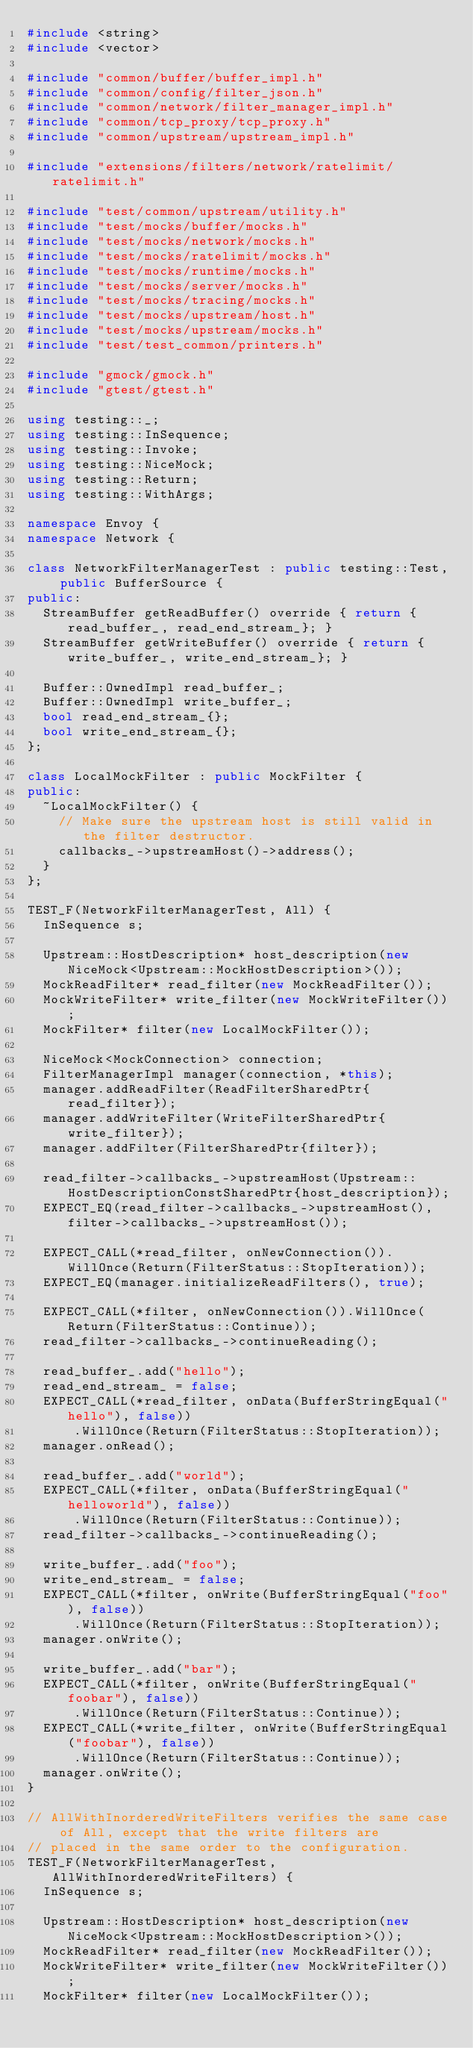Convert code to text. <code><loc_0><loc_0><loc_500><loc_500><_C++_>#include <string>
#include <vector>

#include "common/buffer/buffer_impl.h"
#include "common/config/filter_json.h"
#include "common/network/filter_manager_impl.h"
#include "common/tcp_proxy/tcp_proxy.h"
#include "common/upstream/upstream_impl.h"

#include "extensions/filters/network/ratelimit/ratelimit.h"

#include "test/common/upstream/utility.h"
#include "test/mocks/buffer/mocks.h"
#include "test/mocks/network/mocks.h"
#include "test/mocks/ratelimit/mocks.h"
#include "test/mocks/runtime/mocks.h"
#include "test/mocks/server/mocks.h"
#include "test/mocks/tracing/mocks.h"
#include "test/mocks/upstream/host.h"
#include "test/mocks/upstream/mocks.h"
#include "test/test_common/printers.h"

#include "gmock/gmock.h"
#include "gtest/gtest.h"

using testing::_;
using testing::InSequence;
using testing::Invoke;
using testing::NiceMock;
using testing::Return;
using testing::WithArgs;

namespace Envoy {
namespace Network {

class NetworkFilterManagerTest : public testing::Test, public BufferSource {
public:
  StreamBuffer getReadBuffer() override { return {read_buffer_, read_end_stream_}; }
  StreamBuffer getWriteBuffer() override { return {write_buffer_, write_end_stream_}; }

  Buffer::OwnedImpl read_buffer_;
  Buffer::OwnedImpl write_buffer_;
  bool read_end_stream_{};
  bool write_end_stream_{};
};

class LocalMockFilter : public MockFilter {
public:
  ~LocalMockFilter() {
    // Make sure the upstream host is still valid in the filter destructor.
    callbacks_->upstreamHost()->address();
  }
};

TEST_F(NetworkFilterManagerTest, All) {
  InSequence s;

  Upstream::HostDescription* host_description(new NiceMock<Upstream::MockHostDescription>());
  MockReadFilter* read_filter(new MockReadFilter());
  MockWriteFilter* write_filter(new MockWriteFilter());
  MockFilter* filter(new LocalMockFilter());

  NiceMock<MockConnection> connection;
  FilterManagerImpl manager(connection, *this);
  manager.addReadFilter(ReadFilterSharedPtr{read_filter});
  manager.addWriteFilter(WriteFilterSharedPtr{write_filter});
  manager.addFilter(FilterSharedPtr{filter});

  read_filter->callbacks_->upstreamHost(Upstream::HostDescriptionConstSharedPtr{host_description});
  EXPECT_EQ(read_filter->callbacks_->upstreamHost(), filter->callbacks_->upstreamHost());

  EXPECT_CALL(*read_filter, onNewConnection()).WillOnce(Return(FilterStatus::StopIteration));
  EXPECT_EQ(manager.initializeReadFilters(), true);

  EXPECT_CALL(*filter, onNewConnection()).WillOnce(Return(FilterStatus::Continue));
  read_filter->callbacks_->continueReading();

  read_buffer_.add("hello");
  read_end_stream_ = false;
  EXPECT_CALL(*read_filter, onData(BufferStringEqual("hello"), false))
      .WillOnce(Return(FilterStatus::StopIteration));
  manager.onRead();

  read_buffer_.add("world");
  EXPECT_CALL(*filter, onData(BufferStringEqual("helloworld"), false))
      .WillOnce(Return(FilterStatus::Continue));
  read_filter->callbacks_->continueReading();

  write_buffer_.add("foo");
  write_end_stream_ = false;
  EXPECT_CALL(*filter, onWrite(BufferStringEqual("foo"), false))
      .WillOnce(Return(FilterStatus::StopIteration));
  manager.onWrite();

  write_buffer_.add("bar");
  EXPECT_CALL(*filter, onWrite(BufferStringEqual("foobar"), false))
      .WillOnce(Return(FilterStatus::Continue));
  EXPECT_CALL(*write_filter, onWrite(BufferStringEqual("foobar"), false))
      .WillOnce(Return(FilterStatus::Continue));
  manager.onWrite();
}

// AllWithInorderedWriteFilters verifies the same case of All, except that the write filters are
// placed in the same order to the configuration.
TEST_F(NetworkFilterManagerTest, AllWithInorderedWriteFilters) {
  InSequence s;

  Upstream::HostDescription* host_description(new NiceMock<Upstream::MockHostDescription>());
  MockReadFilter* read_filter(new MockReadFilter());
  MockWriteFilter* write_filter(new MockWriteFilter());
  MockFilter* filter(new LocalMockFilter());
</code> 